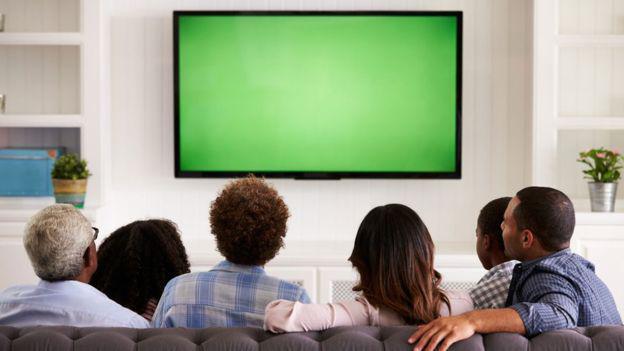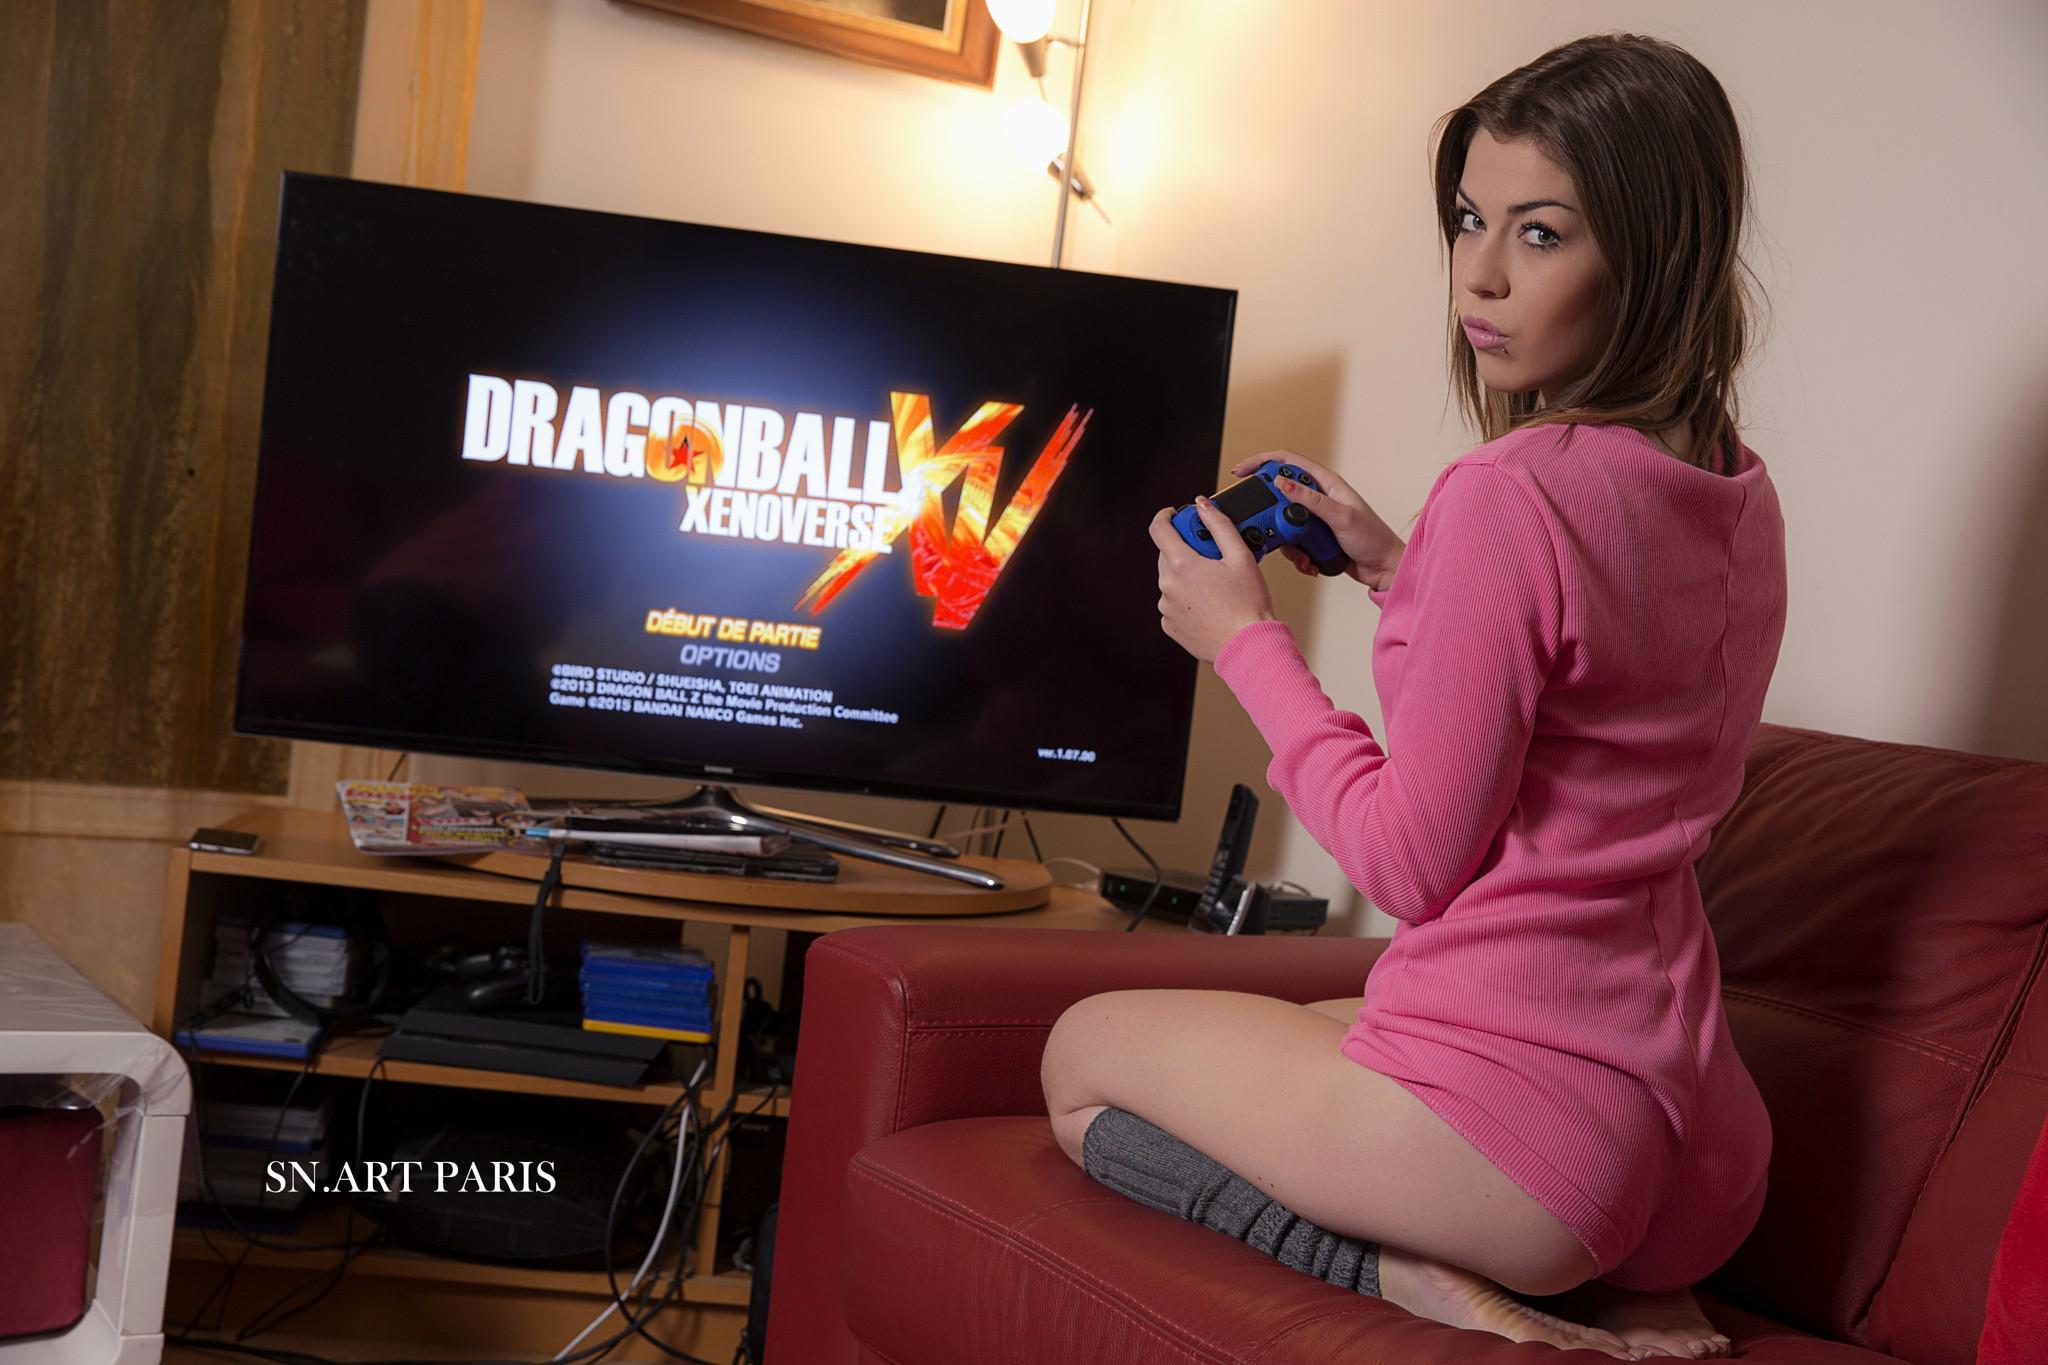The first image is the image on the left, the second image is the image on the right. Considering the images on both sides, is "One of the TVs has a blank green screen." valid? Answer yes or no. Yes. The first image is the image on the left, the second image is the image on the right. For the images displayed, is the sentence "In the right image, a girl sitting on her knees in front of a TV screen has her head turned to look over her shoulder." factually correct? Answer yes or no. Yes. 